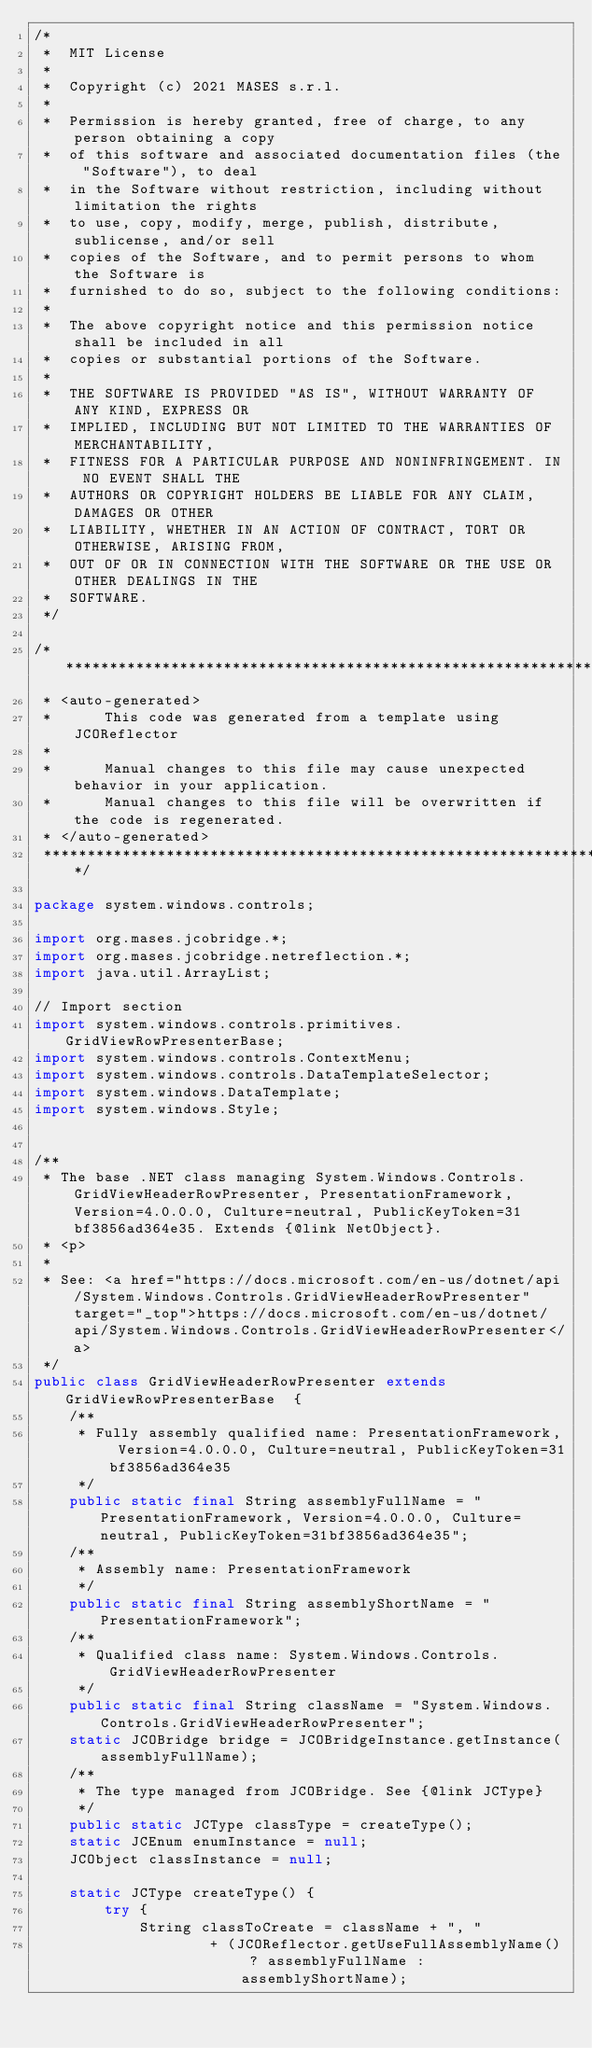<code> <loc_0><loc_0><loc_500><loc_500><_Java_>/*
 *  MIT License
 *
 *  Copyright (c) 2021 MASES s.r.l.
 *
 *  Permission is hereby granted, free of charge, to any person obtaining a copy
 *  of this software and associated documentation files (the "Software"), to deal
 *  in the Software without restriction, including without limitation the rights
 *  to use, copy, modify, merge, publish, distribute, sublicense, and/or sell
 *  copies of the Software, and to permit persons to whom the Software is
 *  furnished to do so, subject to the following conditions:
 *
 *  The above copyright notice and this permission notice shall be included in all
 *  copies or substantial portions of the Software.
 *
 *  THE SOFTWARE IS PROVIDED "AS IS", WITHOUT WARRANTY OF ANY KIND, EXPRESS OR
 *  IMPLIED, INCLUDING BUT NOT LIMITED TO THE WARRANTIES OF MERCHANTABILITY,
 *  FITNESS FOR A PARTICULAR PURPOSE AND NONINFRINGEMENT. IN NO EVENT SHALL THE
 *  AUTHORS OR COPYRIGHT HOLDERS BE LIABLE FOR ANY CLAIM, DAMAGES OR OTHER
 *  LIABILITY, WHETHER IN AN ACTION OF CONTRACT, TORT OR OTHERWISE, ARISING FROM,
 *  OUT OF OR IN CONNECTION WITH THE SOFTWARE OR THE USE OR OTHER DEALINGS IN THE
 *  SOFTWARE.
 */

/**************************************************************************************
 * <auto-generated>
 *      This code was generated from a template using JCOReflector
 * 
 *      Manual changes to this file may cause unexpected behavior in your application.
 *      Manual changes to this file will be overwritten if the code is regenerated.
 * </auto-generated>
 *************************************************************************************/

package system.windows.controls;

import org.mases.jcobridge.*;
import org.mases.jcobridge.netreflection.*;
import java.util.ArrayList;

// Import section
import system.windows.controls.primitives.GridViewRowPresenterBase;
import system.windows.controls.ContextMenu;
import system.windows.controls.DataTemplateSelector;
import system.windows.DataTemplate;
import system.windows.Style;


/**
 * The base .NET class managing System.Windows.Controls.GridViewHeaderRowPresenter, PresentationFramework, Version=4.0.0.0, Culture=neutral, PublicKeyToken=31bf3856ad364e35. Extends {@link NetObject}.
 * <p>
 * 
 * See: <a href="https://docs.microsoft.com/en-us/dotnet/api/System.Windows.Controls.GridViewHeaderRowPresenter" target="_top">https://docs.microsoft.com/en-us/dotnet/api/System.Windows.Controls.GridViewHeaderRowPresenter</a>
 */
public class GridViewHeaderRowPresenter extends GridViewRowPresenterBase  {
    /**
     * Fully assembly qualified name: PresentationFramework, Version=4.0.0.0, Culture=neutral, PublicKeyToken=31bf3856ad364e35
     */
    public static final String assemblyFullName = "PresentationFramework, Version=4.0.0.0, Culture=neutral, PublicKeyToken=31bf3856ad364e35";
    /**
     * Assembly name: PresentationFramework
     */
    public static final String assemblyShortName = "PresentationFramework";
    /**
     * Qualified class name: System.Windows.Controls.GridViewHeaderRowPresenter
     */
    public static final String className = "System.Windows.Controls.GridViewHeaderRowPresenter";
    static JCOBridge bridge = JCOBridgeInstance.getInstance(assemblyFullName);
    /**
     * The type managed from JCOBridge. See {@link JCType}
     */
    public static JCType classType = createType();
    static JCEnum enumInstance = null;
    JCObject classInstance = null;

    static JCType createType() {
        try {
            String classToCreate = className + ", "
                    + (JCOReflector.getUseFullAssemblyName() ? assemblyFullName : assemblyShortName);</code> 